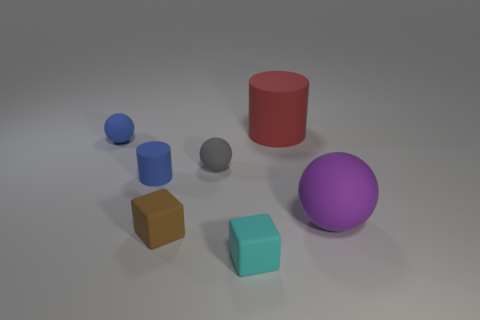Are there fewer tiny cylinders on the right side of the tiny cyan block than green rubber things?
Your response must be concise. No. There is a small blue rubber object that is in front of the small matte object left of the small blue matte object that is in front of the blue sphere; what is its shape?
Your answer should be very brief. Cylinder. Do the tiny brown matte thing and the red thing have the same shape?
Offer a very short reply. No. How many other things are there of the same shape as the red object?
Provide a short and direct response. 1. What is the color of the matte sphere that is the same size as the red object?
Offer a terse response. Purple. Are there an equal number of small blue rubber objects in front of the purple thing and cyan matte cubes?
Give a very brief answer. No. What shape is the matte object that is on the right side of the small cyan cube and left of the large matte ball?
Offer a very short reply. Cylinder. Is the brown rubber block the same size as the blue cylinder?
Offer a terse response. Yes. Is there a small blue thing that has the same material as the small brown thing?
Ensure brevity in your answer.  Yes. What size is the ball that is the same color as the small rubber cylinder?
Your answer should be compact. Small. 